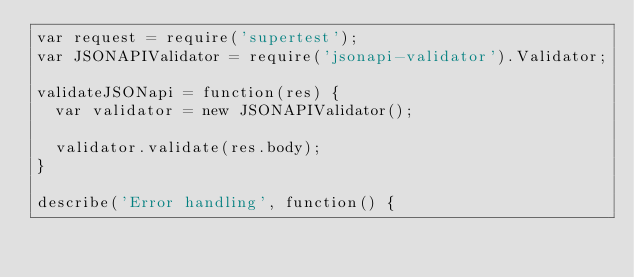Convert code to text. <code><loc_0><loc_0><loc_500><loc_500><_JavaScript_>var request = require('supertest');
var JSONAPIValidator = require('jsonapi-validator').Validator;

validateJSONapi = function(res) {
  var validator = new JSONAPIValidator();

  validator.validate(res.body);
}

describe('Error handling', function() {</code> 